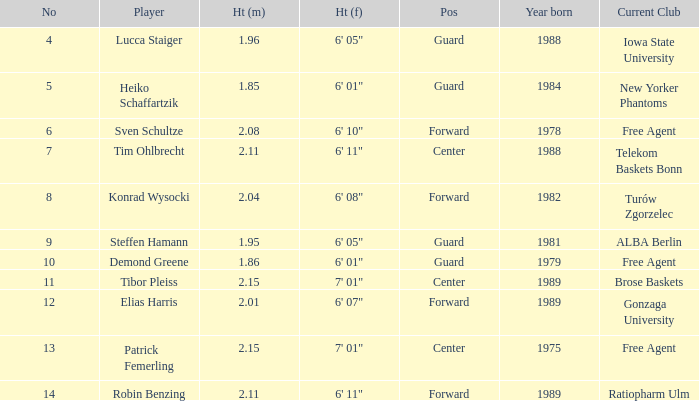I'm looking to parse the entire table for insights. Could you assist me with that? {'header': ['No', 'Player', 'Ht (m)', 'Ht (f)', 'Pos', 'Year born', 'Current Club'], 'rows': [['4', 'Lucca Staiger', '1.96', '6\' 05"', 'Guard', '1988', 'Iowa State University'], ['5', 'Heiko Schaffartzik', '1.85', '6\' 01"', 'Guard', '1984', 'New Yorker Phantoms'], ['6', 'Sven Schultze', '2.08', '6\' 10"', 'Forward', '1978', 'Free Agent'], ['7', 'Tim Ohlbrecht', '2.11', '6\' 11"', 'Center', '1988', 'Telekom Baskets Bonn'], ['8', 'Konrad Wysocki', '2.04', '6\' 08"', 'Forward', '1982', 'Turów Zgorzelec'], ['9', 'Steffen Hamann', '1.95', '6\' 05"', 'Guard', '1981', 'ALBA Berlin'], ['10', 'Demond Greene', '1.86', '6\' 01"', 'Guard', '1979', 'Free Agent'], ['11', 'Tibor Pleiss', '2.15', '7\' 01"', 'Center', '1989', 'Brose Baskets'], ['12', 'Elias Harris', '2.01', '6\' 07"', 'Forward', '1989', 'Gonzaga University'], ['13', 'Patrick Femerling', '2.15', '7\' 01"', 'Center', '1975', 'Free Agent'], ['14', 'Robin Benzing', '2.11', '6\' 11"', 'Forward', '1989', 'Ratiopharm Ulm']]} How tall is demond greene? 6' 01". 